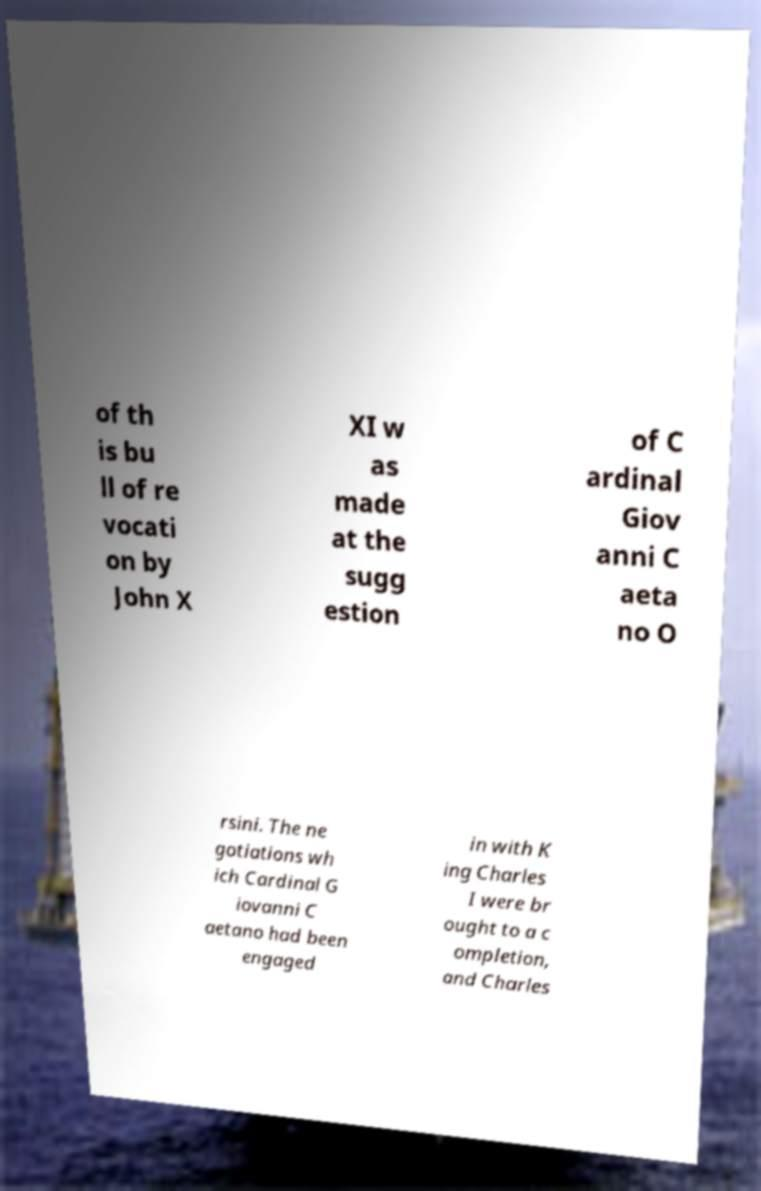Please read and relay the text visible in this image. What does it say? of th is bu ll of re vocati on by John X XI w as made at the sugg estion of C ardinal Giov anni C aeta no O rsini. The ne gotiations wh ich Cardinal G iovanni C aetano had been engaged in with K ing Charles I were br ought to a c ompletion, and Charles 